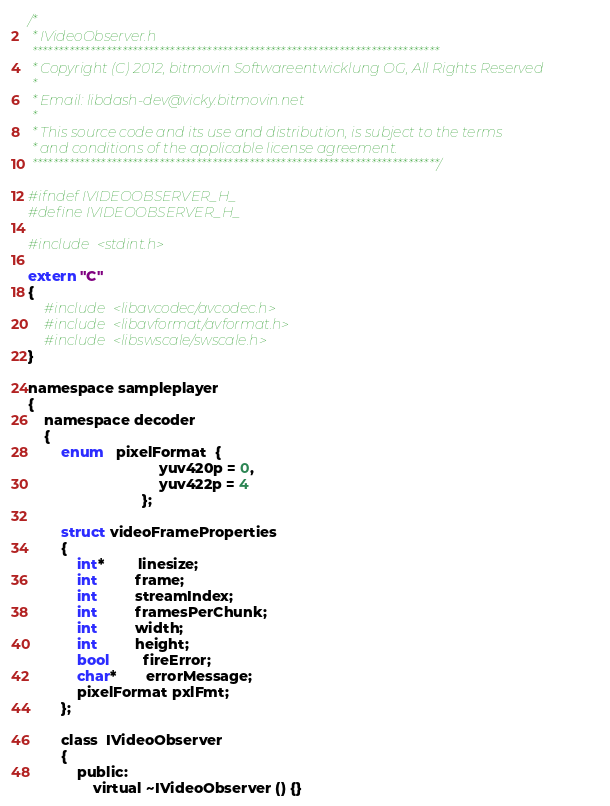<code> <loc_0><loc_0><loc_500><loc_500><_C_>/*
 * IVideoObserver.h
 *****************************************************************************
 * Copyright (C) 2012, bitmovin Softwareentwicklung OG, All Rights Reserved
 *
 * Email: libdash-dev@vicky.bitmovin.net
 *
 * This source code and its use and distribution, is subject to the terms
 * and conditions of the applicable license agreement.
 *****************************************************************************/

#ifndef IVIDEOOBSERVER_H_
#define IVIDEOOBSERVER_H_

#include <stdint.h>

extern "C"
{
    #include <libavcodec/avcodec.h>
    #include <libavformat/avformat.h>
    #include <libswscale/swscale.h>
}

namespace sampleplayer
{
    namespace decoder
    {
        enum   pixelFormat  {
                                yuv420p = 0,
                                yuv422p = 4
                            };

        struct videoFrameProperties
        {
            int*        linesize;
            int         frame;
            int         streamIndex;
            int         framesPerChunk;
            int         width;
            int         height;
            bool        fireError;
            char*       errorMessage;
            pixelFormat pxlFmt;
        };

        class  IVideoObserver
        {
            public:
                virtual ~IVideoObserver () {}
</code> 